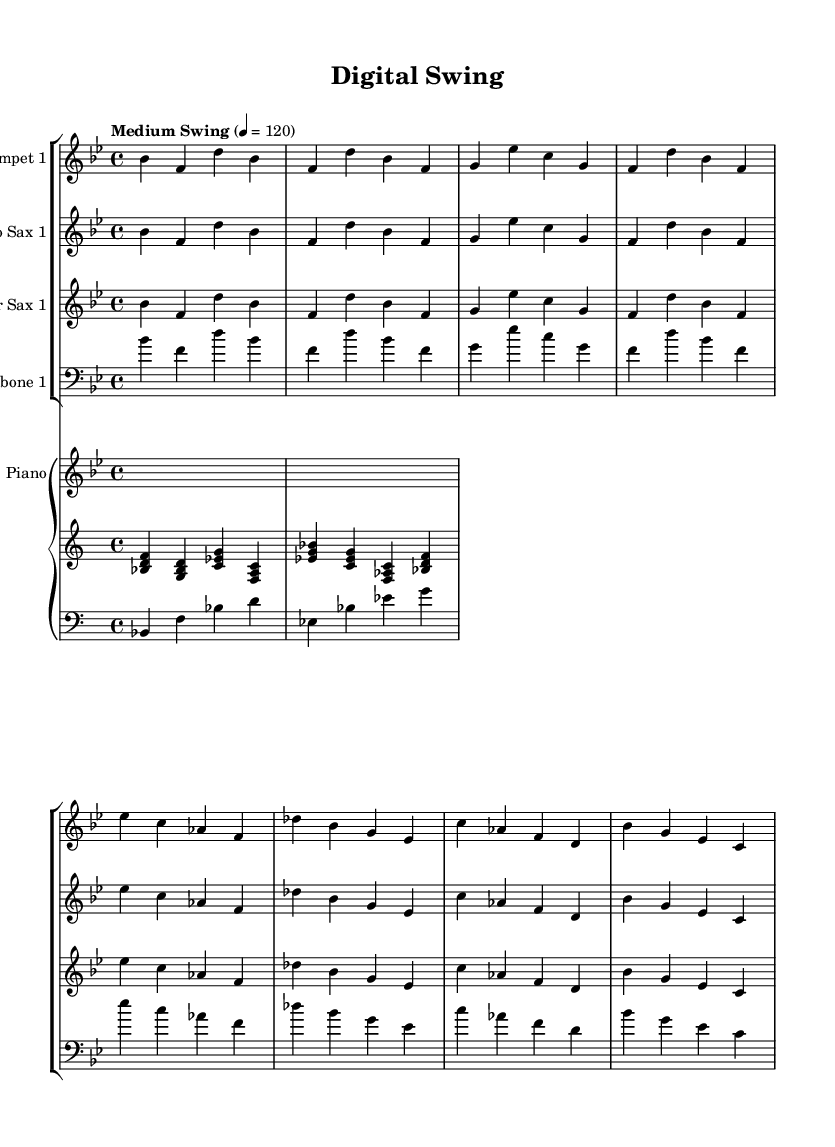What is the key signature of this music? The key signature is B flat major, indicated by two flat symbols (B flat and E flat) at the beginning of the staff.
Answer: B flat major What is the time signature of this music? The time signature is 4/4, which means there are four beats in each measure and the quarter note gets one beat, as shown at the beginning of the score.
Answer: 4/4 What is the tempo marking of this piece? The tempo marking is "Medium Swing," which suggests a moderate swing feel, and the metronome marking indicates 120 beats per minute.
Answer: Medium Swing How many sections are in the main theme? The main theme is composed of two distinct sections, as indicated by the repeated patterns labeled in the sheet music.
Answer: Two sections Which instruments are featured in the arrangement? The arrangement features trumpet, alto saxophone, tenor saxophone, trombone, and piano, as indicated by their respective instrument names at the beginning of each staff.
Answer: Trumpet, Alto Saxophone, Tenor Saxophone, Trombone, Piano What is the role of the piano in this big band arrangement? The piano in this arrangement provides both rhythmic and harmonic support, demonstrated by the combination of treble and bass clefs, playing chords and a bass line.
Answer: Rhythmic and harmonic support What jazz style is primarily represented in this piece? The piece primarily represents a big band jazz style, characterized by its orchestration for various brass and woodwind instruments and the rhythmic swing feel.
Answer: Big band jazz 